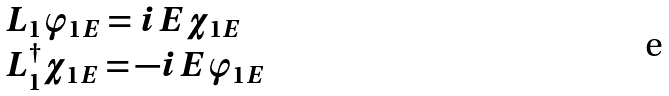Convert formula to latex. <formula><loc_0><loc_0><loc_500><loc_500>\begin{array} { l } L _ { 1 } \varphi _ { 1 E } = i E \chi _ { 1 E } \\ L _ { 1 } ^ { \dag } \chi _ { 1 E } = - i E \varphi _ { 1 E } \end{array}</formula> 